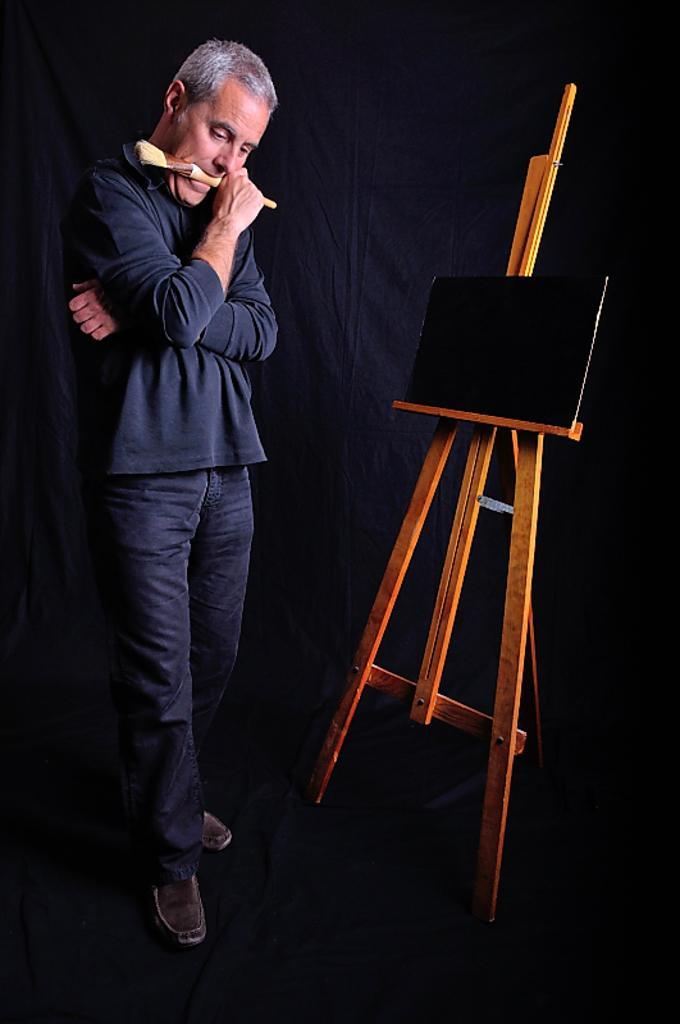Please provide a concise description of this image. In this picture we can see a man is holding a brush and in front of the man there is a wooden stand with a board. Behind the man there is a dark background. 